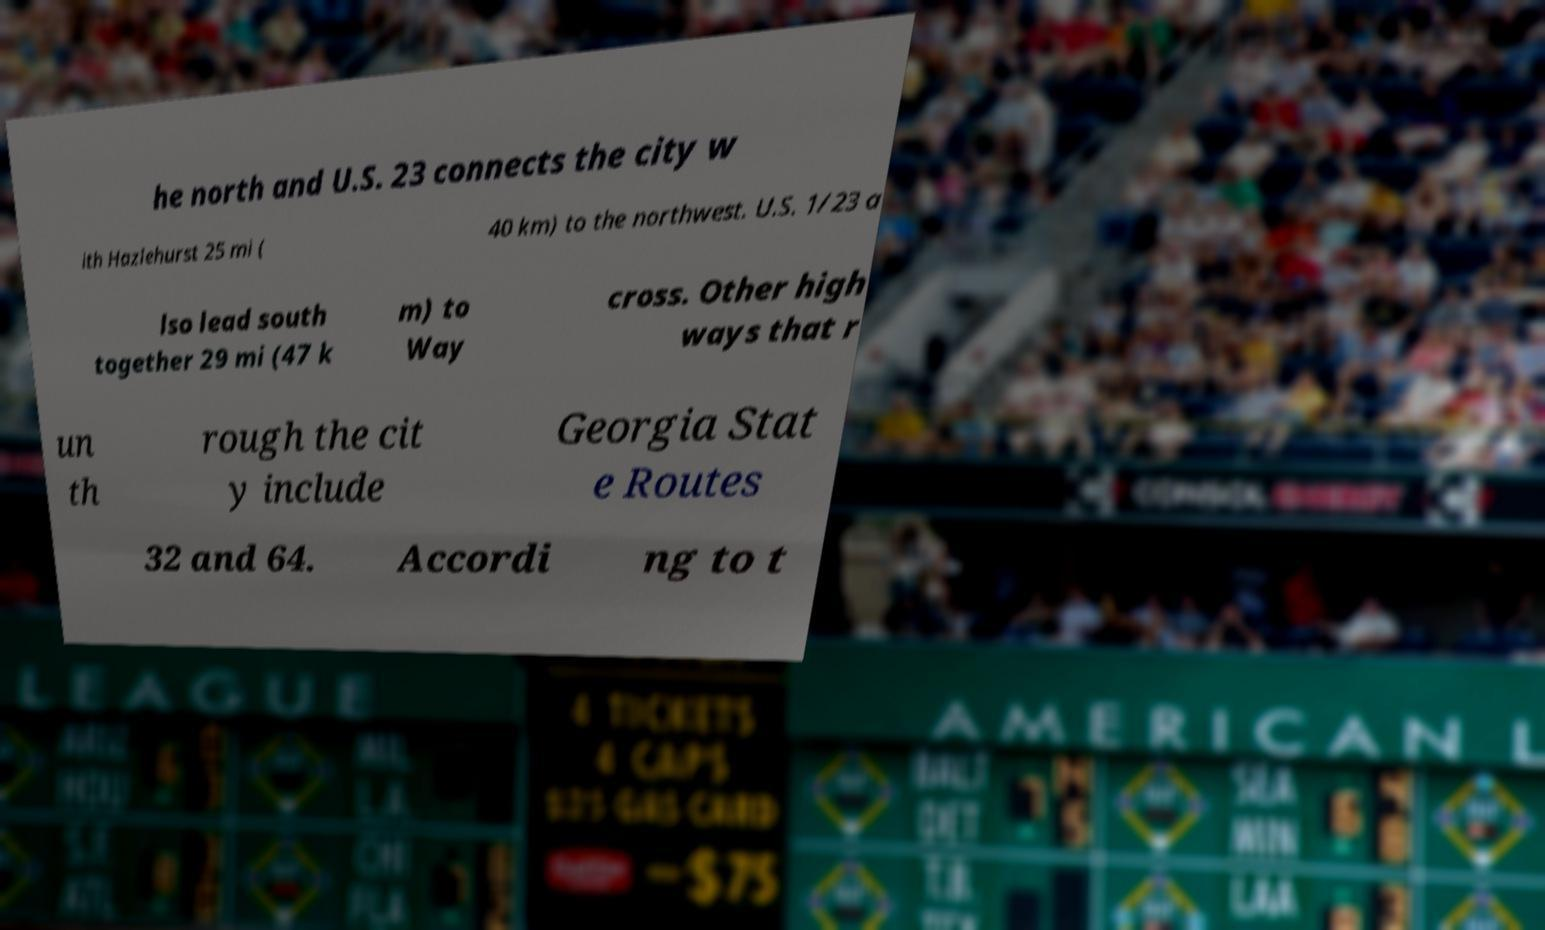Could you extract and type out the text from this image? he north and U.S. 23 connects the city w ith Hazlehurst 25 mi ( 40 km) to the northwest. U.S. 1/23 a lso lead south together 29 mi (47 k m) to Way cross. Other high ways that r un th rough the cit y include Georgia Stat e Routes 32 and 64. Accordi ng to t 